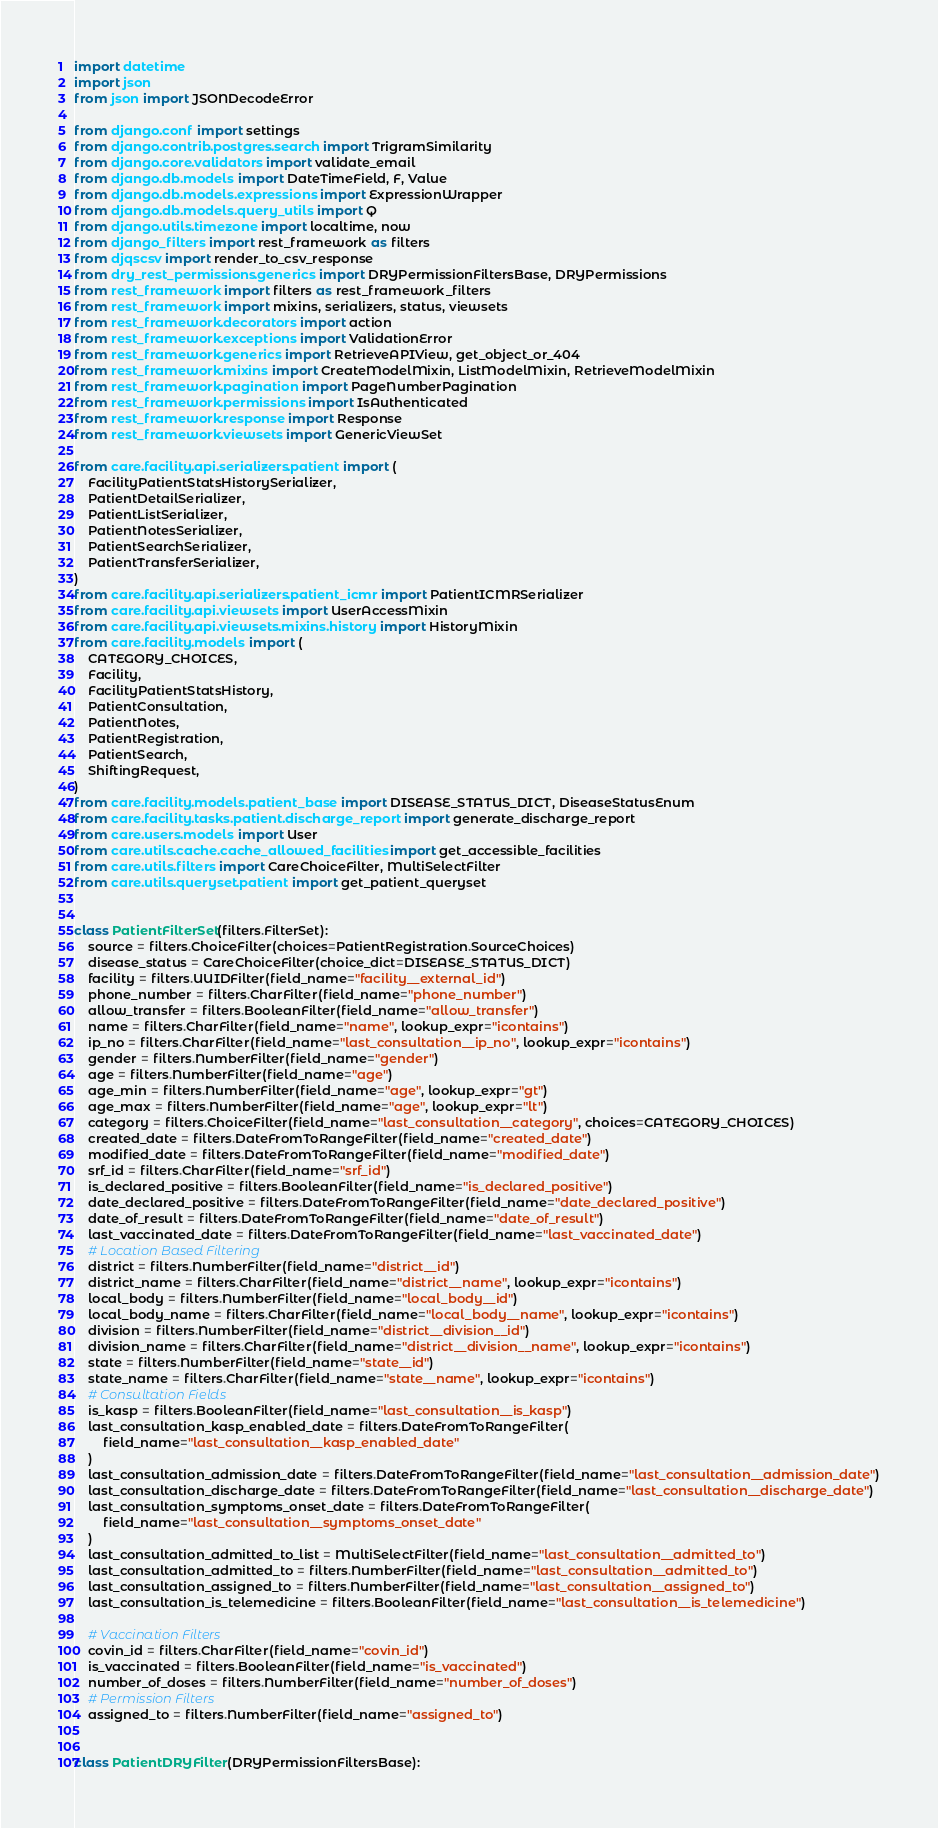<code> <loc_0><loc_0><loc_500><loc_500><_Python_>import datetime
import json
from json import JSONDecodeError

from django.conf import settings
from django.contrib.postgres.search import TrigramSimilarity
from django.core.validators import validate_email
from django.db.models import DateTimeField, F, Value
from django.db.models.expressions import ExpressionWrapper
from django.db.models.query_utils import Q
from django.utils.timezone import localtime, now
from django_filters import rest_framework as filters
from djqscsv import render_to_csv_response
from dry_rest_permissions.generics import DRYPermissionFiltersBase, DRYPermissions
from rest_framework import filters as rest_framework_filters
from rest_framework import mixins, serializers, status, viewsets
from rest_framework.decorators import action
from rest_framework.exceptions import ValidationError
from rest_framework.generics import RetrieveAPIView, get_object_or_404
from rest_framework.mixins import CreateModelMixin, ListModelMixin, RetrieveModelMixin
from rest_framework.pagination import PageNumberPagination
from rest_framework.permissions import IsAuthenticated
from rest_framework.response import Response
from rest_framework.viewsets import GenericViewSet

from care.facility.api.serializers.patient import (
    FacilityPatientStatsHistorySerializer,
    PatientDetailSerializer,
    PatientListSerializer,
    PatientNotesSerializer,
    PatientSearchSerializer,
    PatientTransferSerializer,
)
from care.facility.api.serializers.patient_icmr import PatientICMRSerializer
from care.facility.api.viewsets import UserAccessMixin
from care.facility.api.viewsets.mixins.history import HistoryMixin
from care.facility.models import (
    CATEGORY_CHOICES,
    Facility,
    FacilityPatientStatsHistory,
    PatientConsultation,
    PatientNotes,
    PatientRegistration,
    PatientSearch,
    ShiftingRequest,
)
from care.facility.models.patient_base import DISEASE_STATUS_DICT, DiseaseStatusEnum
from care.facility.tasks.patient.discharge_report import generate_discharge_report
from care.users.models import User
from care.utils.cache.cache_allowed_facilities import get_accessible_facilities
from care.utils.filters import CareChoiceFilter, MultiSelectFilter
from care.utils.queryset.patient import get_patient_queryset


class PatientFilterSet(filters.FilterSet):
    source = filters.ChoiceFilter(choices=PatientRegistration.SourceChoices)
    disease_status = CareChoiceFilter(choice_dict=DISEASE_STATUS_DICT)
    facility = filters.UUIDFilter(field_name="facility__external_id")
    phone_number = filters.CharFilter(field_name="phone_number")
    allow_transfer = filters.BooleanFilter(field_name="allow_transfer")
    name = filters.CharFilter(field_name="name", lookup_expr="icontains")
    ip_no = filters.CharFilter(field_name="last_consultation__ip_no", lookup_expr="icontains")
    gender = filters.NumberFilter(field_name="gender")
    age = filters.NumberFilter(field_name="age")
    age_min = filters.NumberFilter(field_name="age", lookup_expr="gt")
    age_max = filters.NumberFilter(field_name="age", lookup_expr="lt")
    category = filters.ChoiceFilter(field_name="last_consultation__category", choices=CATEGORY_CHOICES)
    created_date = filters.DateFromToRangeFilter(field_name="created_date")
    modified_date = filters.DateFromToRangeFilter(field_name="modified_date")
    srf_id = filters.CharFilter(field_name="srf_id")
    is_declared_positive = filters.BooleanFilter(field_name="is_declared_positive")
    date_declared_positive = filters.DateFromToRangeFilter(field_name="date_declared_positive")
    date_of_result = filters.DateFromToRangeFilter(field_name="date_of_result")
    last_vaccinated_date = filters.DateFromToRangeFilter(field_name="last_vaccinated_date")
    # Location Based Filtering
    district = filters.NumberFilter(field_name="district__id")
    district_name = filters.CharFilter(field_name="district__name", lookup_expr="icontains")
    local_body = filters.NumberFilter(field_name="local_body__id")
    local_body_name = filters.CharFilter(field_name="local_body__name", lookup_expr="icontains")
    division = filters.NumberFilter(field_name="district__division__id")
    division_name = filters.CharFilter(field_name="district__division__name", lookup_expr="icontains")
    state = filters.NumberFilter(field_name="state__id")
    state_name = filters.CharFilter(field_name="state__name", lookup_expr="icontains")
    # Consultation Fields
    is_kasp = filters.BooleanFilter(field_name="last_consultation__is_kasp")
    last_consultation_kasp_enabled_date = filters.DateFromToRangeFilter(
        field_name="last_consultation__kasp_enabled_date"
    )
    last_consultation_admission_date = filters.DateFromToRangeFilter(field_name="last_consultation__admission_date")
    last_consultation_discharge_date = filters.DateFromToRangeFilter(field_name="last_consultation__discharge_date")
    last_consultation_symptoms_onset_date = filters.DateFromToRangeFilter(
        field_name="last_consultation__symptoms_onset_date"
    )
    last_consultation_admitted_to_list = MultiSelectFilter(field_name="last_consultation__admitted_to")
    last_consultation_admitted_to = filters.NumberFilter(field_name="last_consultation__admitted_to")
    last_consultation_assigned_to = filters.NumberFilter(field_name="last_consultation__assigned_to")
    last_consultation_is_telemedicine = filters.BooleanFilter(field_name="last_consultation__is_telemedicine")

    # Vaccination Filters
    covin_id = filters.CharFilter(field_name="covin_id")
    is_vaccinated = filters.BooleanFilter(field_name="is_vaccinated")
    number_of_doses = filters.NumberFilter(field_name="number_of_doses")
    # Permission Filters
    assigned_to = filters.NumberFilter(field_name="assigned_to")


class PatientDRYFilter(DRYPermissionFiltersBase):</code> 